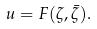Convert formula to latex. <formula><loc_0><loc_0><loc_500><loc_500>u = F ( \zeta , \bar { \zeta } ) .</formula> 